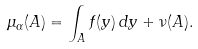Convert formula to latex. <formula><loc_0><loc_0><loc_500><loc_500>\mu _ { \alpha } ( A ) = \int _ { A } f ( y ) \, d y + \nu ( A ) .</formula> 